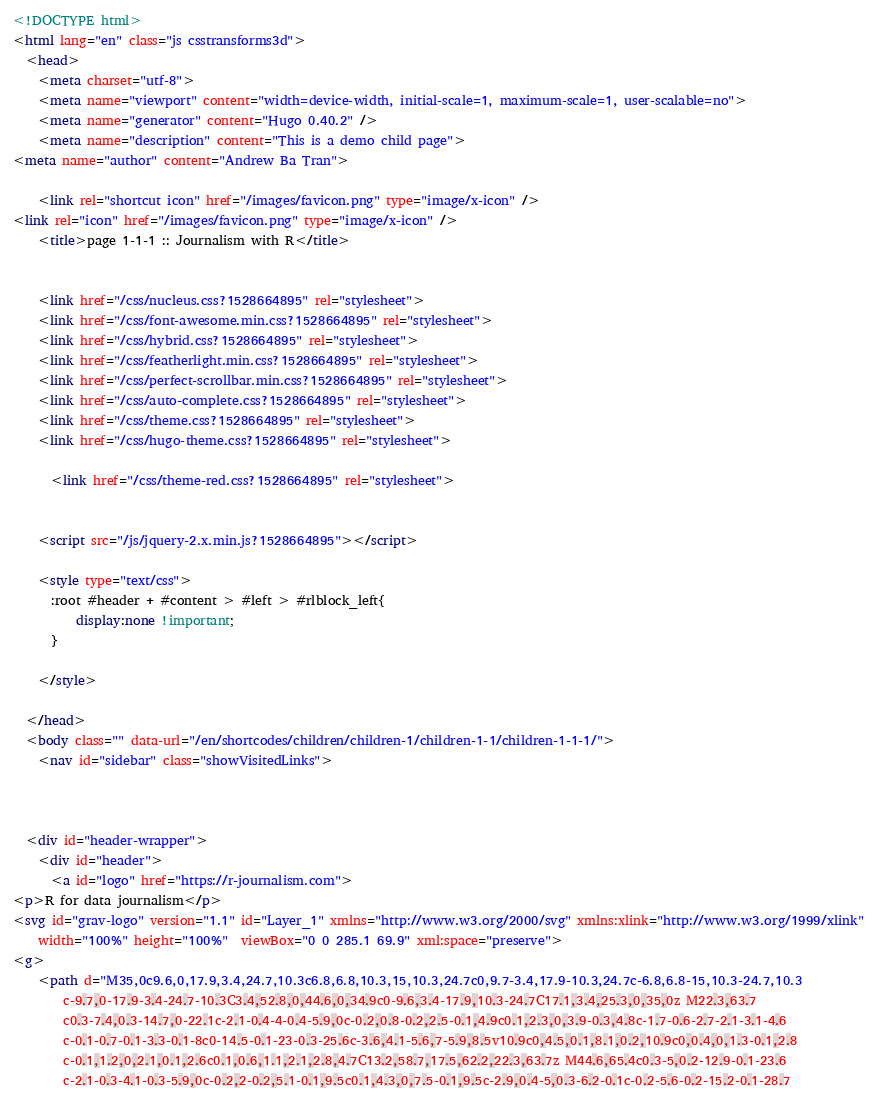<code> <loc_0><loc_0><loc_500><loc_500><_HTML_><!DOCTYPE html>
<html lang="en" class="js csstransforms3d">
  <head>
    <meta charset="utf-8">
    <meta name="viewport" content="width=device-width, initial-scale=1, maximum-scale=1, user-scalable=no">
    <meta name="generator" content="Hugo 0.40.2" />
    <meta name="description" content="This is a demo child page">
<meta name="author" content="Andrew Ba Tran">

    <link rel="shortcut icon" href="/images/favicon.png" type="image/x-icon" />
<link rel="icon" href="/images/favicon.png" type="image/x-icon" />
    <title>page 1-1-1 :: Journalism with R</title>
    
    
    <link href="/css/nucleus.css?1528664895" rel="stylesheet">
    <link href="/css/font-awesome.min.css?1528664895" rel="stylesheet">
    <link href="/css/hybrid.css?1528664895" rel="stylesheet">
    <link href="/css/featherlight.min.css?1528664895" rel="stylesheet">
    <link href="/css/perfect-scrollbar.min.css?1528664895" rel="stylesheet">
    <link href="/css/auto-complete.css?1528664895" rel="stylesheet">
    <link href="/css/theme.css?1528664895" rel="stylesheet">
    <link href="/css/hugo-theme.css?1528664895" rel="stylesheet">
    
      <link href="/css/theme-red.css?1528664895" rel="stylesheet">
    

    <script src="/js/jquery-2.x.min.js?1528664895"></script>
    
    <style type="text/css">
      :root #header + #content > #left > #rlblock_left{ 
          display:none !important;
      }
      
    </style>
    
  </head>
  <body class="" data-url="/en/shortcodes/children/children-1/children-1-1/children-1-1-1/">
    <nav id="sidebar" class="showVisitedLinks">



  <div id="header-wrapper">
    <div id="header">
      <a id="logo" href="https://r-journalism.com">
<p>R for data journalism</p>
<svg id="grav-logo" version="1.1" id="Layer_1" xmlns="http://www.w3.org/2000/svg" xmlns:xlink="http://www.w3.org/1999/xlink"
	width="100%" height="100%"  viewBox="0 0 285.1 69.9" xml:space="preserve">
<g>
	<path d="M35,0c9.6,0,17.9,3.4,24.7,10.3c6.8,6.8,10.3,15,10.3,24.7c0,9.7-3.4,17.9-10.3,24.7c-6.8,6.8-15,10.3-24.7,10.3
		c-9.7,0-17.9-3.4-24.7-10.3C3.4,52.8,0,44.6,0,34.9c0-9.6,3.4-17.9,10.3-24.7C17.1,3.4,25.3,0,35,0z M22.3,63.7
		c0.3-7.4,0.3-14.7,0-22.1c-2.1-0.4-4-0.4-5.9,0c-0.2,0.8-0.2,2.5-0.1,4.9c0.1,2.3,0,3.9-0.3,4.8c-1.7-0.6-2.7-2.1-3.1-4.6
		c-0.1-0.7-0.1-3.3-0.1-8c0-14.5-0.1-23-0.3-25.6c-3.6,4.1-5.6,7-5.9,8.5v10.9c0,4.5,0.1,8.1,0.2,10.9c0,0.4,0,1.3-0.1,2.8
		c-0.1,1.2,0,2.1,0.1,2.6c0.1,0.6,1.1,2.1,2.8,4.7C13.2,58.7,17.5,62.2,22.3,63.7z M44.6,65.4c0.3-5,0.2-12.9-0.1-23.6
		c-2.1-0.3-4.1-0.3-5.9,0c-0.2,2-0.2,5.1-0.1,9.5c0.1,4.3,0,7.5-0.1,9.5c-2.9,0.4-5,0.3-6.2-0.1c-0.2-5.6-0.2-15.2-0.1-28.7</code> 